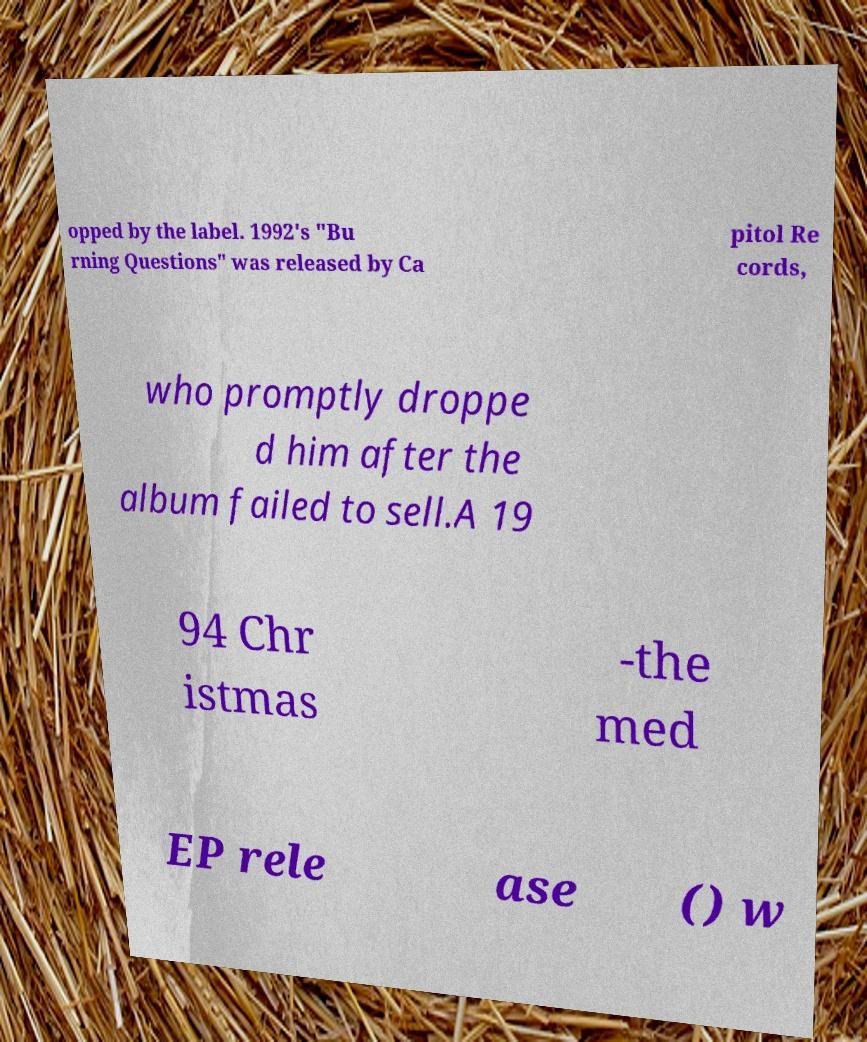What messages or text are displayed in this image? I need them in a readable, typed format. opped by the label. 1992's "Bu rning Questions" was released by Ca pitol Re cords, who promptly droppe d him after the album failed to sell.A 19 94 Chr istmas -the med EP rele ase () w 